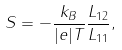Convert formula to latex. <formula><loc_0><loc_0><loc_500><loc_500>S = - \frac { k _ { B } } { | e | T } \frac { L _ { 1 2 } } { L _ { 1 1 } } ,</formula> 